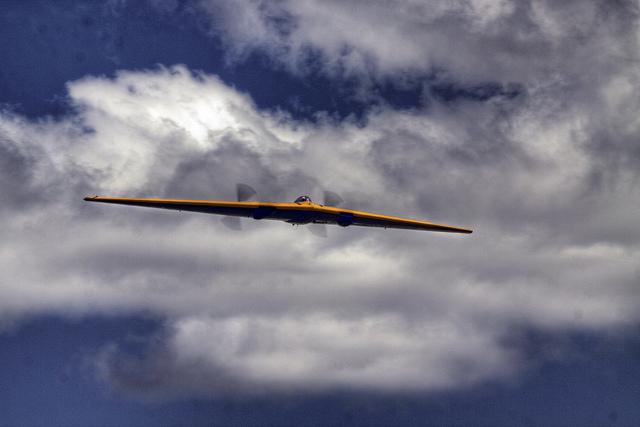How was this picture taken?
Write a very short answer. Telephoto lens. Is the sky clear?
Be succinct. No. What color is the plane?
Answer briefly. Yellow. What type of plane is in the photo?
Keep it brief. Glider. Is the plane polluting the air?
Give a very brief answer. Yes. 